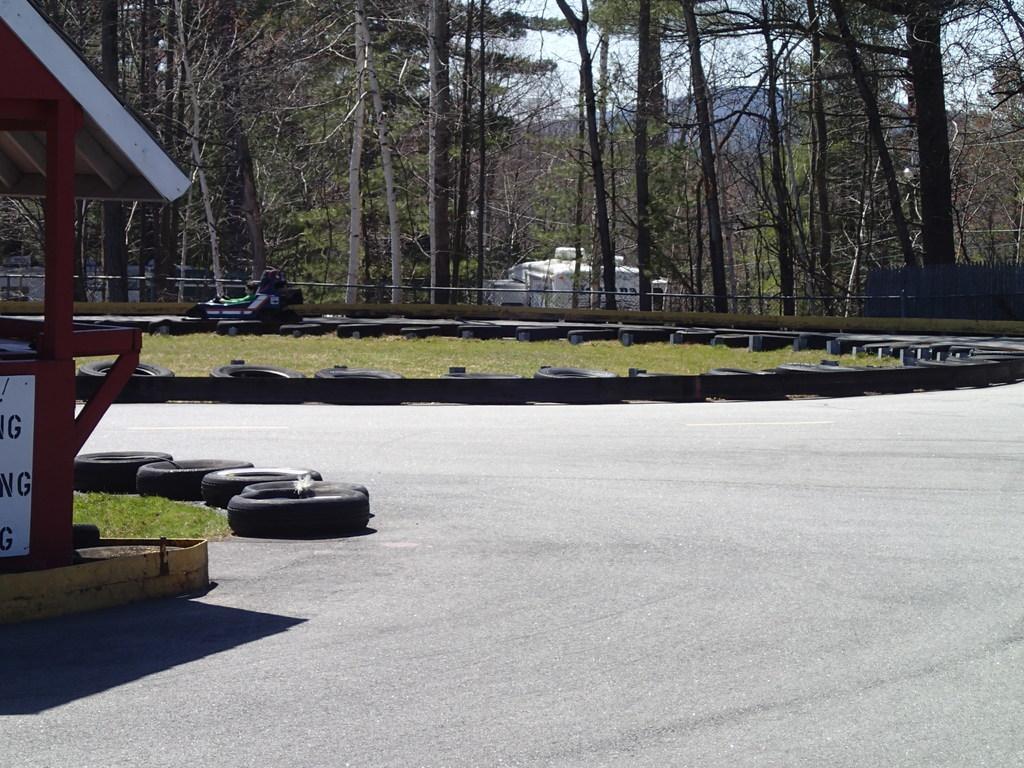In one or two sentences, can you explain what this image depicts? In the picture there is a go-karting area and behind that area there are tall trees. 